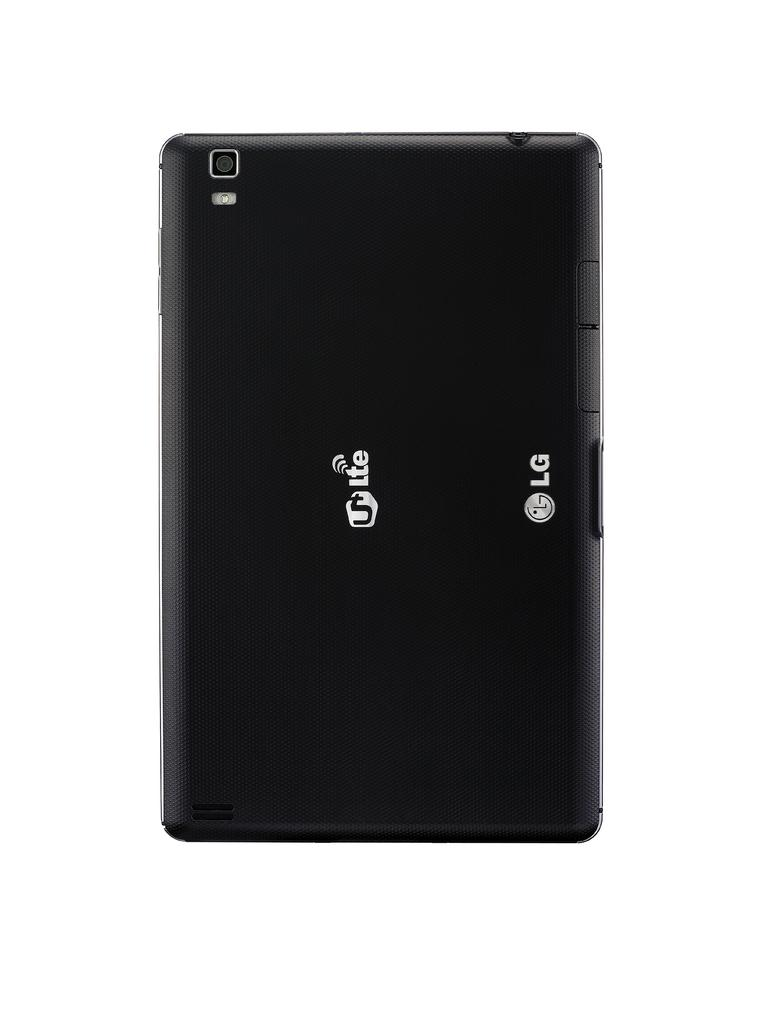<image>
Describe the image concisely. It's the back of a black LG phone with white Lte letters in the center. 